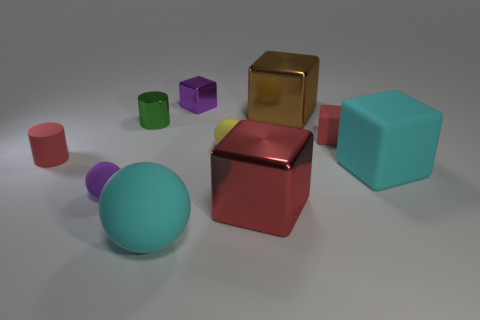Subtract all brown blocks. How many blocks are left? 4 Subtract all tiny matte spheres. How many spheres are left? 1 Subtract all purple blocks. Subtract all blue spheres. How many blocks are left? 4 Subtract all cylinders. How many objects are left? 8 Add 5 brown cubes. How many brown cubes are left? 6 Add 5 red matte things. How many red matte things exist? 7 Subtract 0 gray spheres. How many objects are left? 10 Subtract all cyan matte things. Subtract all red shiny objects. How many objects are left? 7 